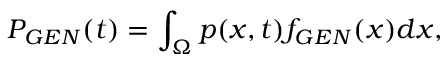Convert formula to latex. <formula><loc_0><loc_0><loc_500><loc_500>P _ { G E N } ( t ) = \int _ { \Omega } p ( x , t ) f _ { G E N } ( x ) d x ,</formula> 